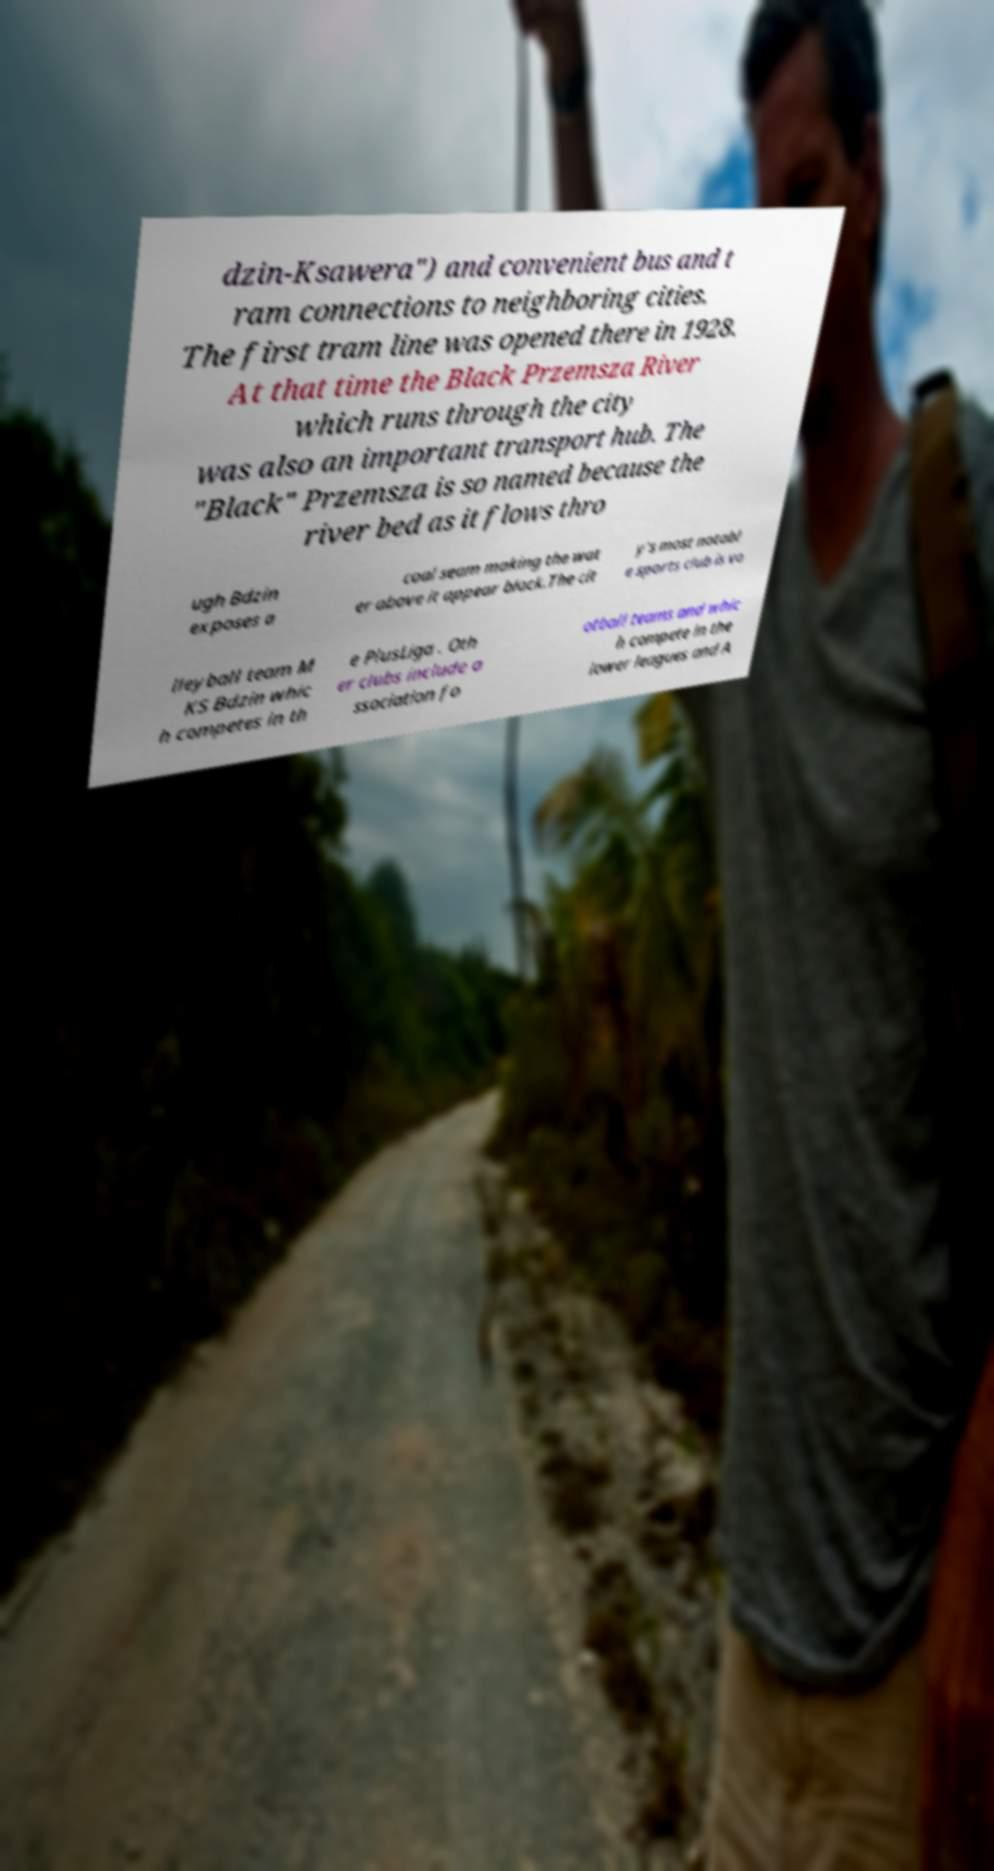Could you extract and type out the text from this image? dzin-Ksawera") and convenient bus and t ram connections to neighboring cities. The first tram line was opened there in 1928. At that time the Black Przemsza River which runs through the city was also an important transport hub. The "Black" Przemsza is so named because the river bed as it flows thro ugh Bdzin exposes a coal seam making the wat er above it appear black.The cit y's most notabl e sports club is vo lleyball team M KS Bdzin whic h competes in th e PlusLiga . Oth er clubs include a ssociation fo otball teams and whic h compete in the lower leagues and A 